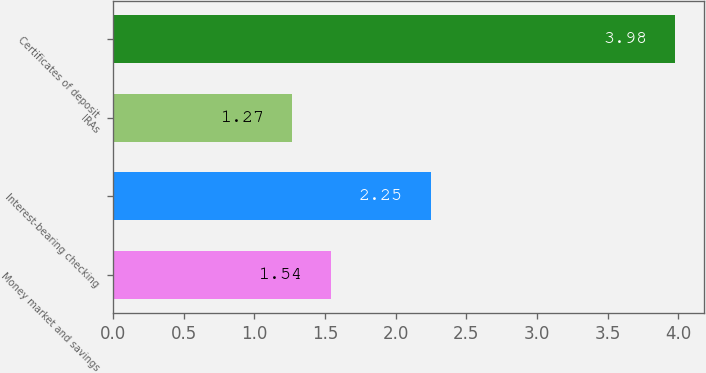Convert chart to OTSL. <chart><loc_0><loc_0><loc_500><loc_500><bar_chart><fcel>Money market and savings<fcel>Interest-bearing checking<fcel>IRAs<fcel>Certificates of deposit<nl><fcel>1.54<fcel>2.25<fcel>1.27<fcel>3.98<nl></chart> 